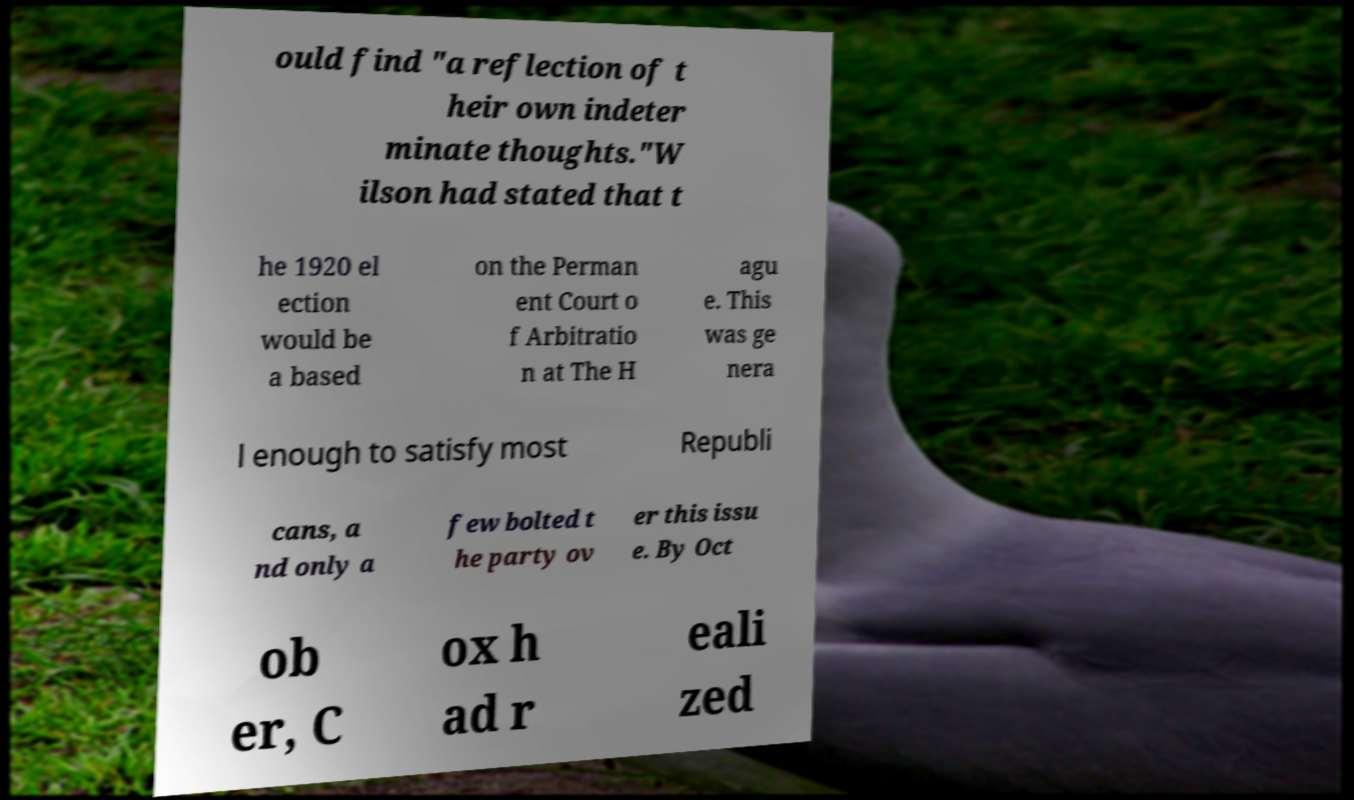Please identify and transcribe the text found in this image. ould find "a reflection of t heir own indeter minate thoughts."W ilson had stated that t he 1920 el ection would be a based on the Perman ent Court o f Arbitratio n at The H agu e. This was ge nera l enough to satisfy most Republi cans, a nd only a few bolted t he party ov er this issu e. By Oct ob er, C ox h ad r eali zed 